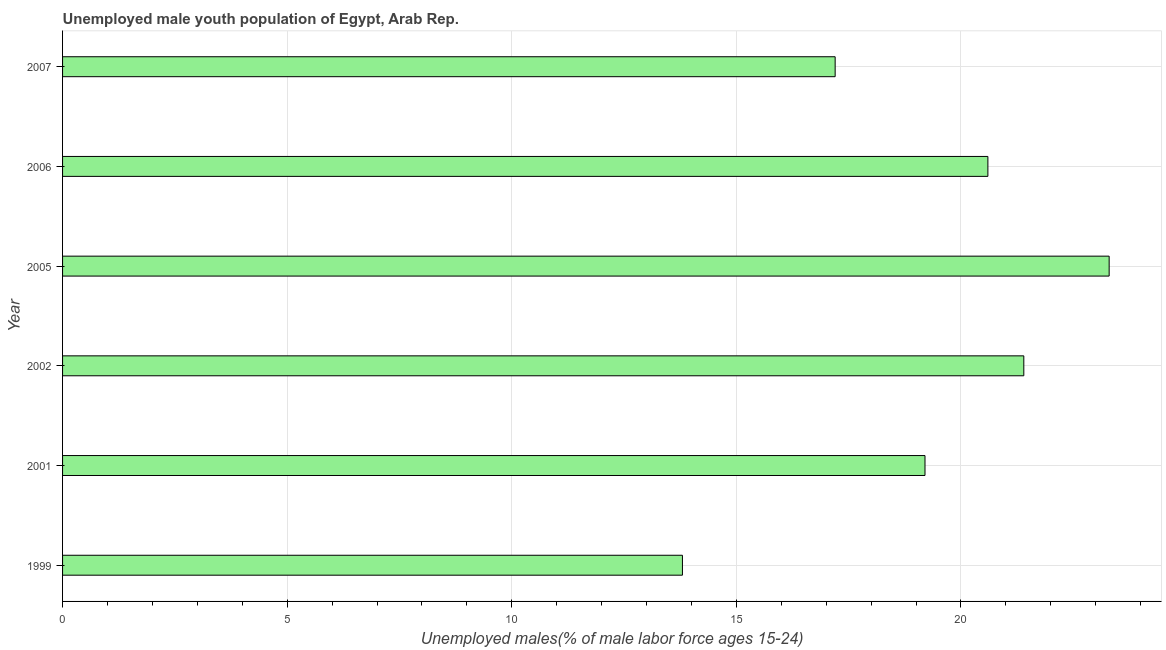What is the title of the graph?
Make the answer very short. Unemployed male youth population of Egypt, Arab Rep. What is the label or title of the X-axis?
Make the answer very short. Unemployed males(% of male labor force ages 15-24). What is the unemployed male youth in 2007?
Ensure brevity in your answer.  17.2. Across all years, what is the maximum unemployed male youth?
Ensure brevity in your answer.  23.3. Across all years, what is the minimum unemployed male youth?
Your answer should be very brief. 13.8. In which year was the unemployed male youth maximum?
Make the answer very short. 2005. What is the sum of the unemployed male youth?
Keep it short and to the point. 115.5. What is the average unemployed male youth per year?
Provide a short and direct response. 19.25. What is the median unemployed male youth?
Give a very brief answer. 19.9. In how many years, is the unemployed male youth greater than 6 %?
Provide a short and direct response. 6. Do a majority of the years between 1999 and 2006 (inclusive) have unemployed male youth greater than 17 %?
Ensure brevity in your answer.  Yes. What is the ratio of the unemployed male youth in 2006 to that in 2007?
Make the answer very short. 1.2. Is the sum of the unemployed male youth in 2002 and 2007 greater than the maximum unemployed male youth across all years?
Provide a succinct answer. Yes. What is the Unemployed males(% of male labor force ages 15-24) in 1999?
Provide a succinct answer. 13.8. What is the Unemployed males(% of male labor force ages 15-24) of 2001?
Ensure brevity in your answer.  19.2. What is the Unemployed males(% of male labor force ages 15-24) in 2002?
Your answer should be compact. 21.4. What is the Unemployed males(% of male labor force ages 15-24) in 2005?
Ensure brevity in your answer.  23.3. What is the Unemployed males(% of male labor force ages 15-24) of 2006?
Make the answer very short. 20.6. What is the Unemployed males(% of male labor force ages 15-24) in 2007?
Provide a succinct answer. 17.2. What is the difference between the Unemployed males(% of male labor force ages 15-24) in 1999 and 2001?
Ensure brevity in your answer.  -5.4. What is the difference between the Unemployed males(% of male labor force ages 15-24) in 1999 and 2002?
Offer a very short reply. -7.6. What is the difference between the Unemployed males(% of male labor force ages 15-24) in 2001 and 2002?
Keep it short and to the point. -2.2. What is the difference between the Unemployed males(% of male labor force ages 15-24) in 2001 and 2005?
Offer a terse response. -4.1. What is the difference between the Unemployed males(% of male labor force ages 15-24) in 2001 and 2006?
Keep it short and to the point. -1.4. What is the difference between the Unemployed males(% of male labor force ages 15-24) in 2001 and 2007?
Your response must be concise. 2. What is the difference between the Unemployed males(% of male labor force ages 15-24) in 2002 and 2006?
Make the answer very short. 0.8. What is the difference between the Unemployed males(% of male labor force ages 15-24) in 2002 and 2007?
Your answer should be very brief. 4.2. What is the difference between the Unemployed males(% of male labor force ages 15-24) in 2005 and 2007?
Ensure brevity in your answer.  6.1. What is the difference between the Unemployed males(% of male labor force ages 15-24) in 2006 and 2007?
Offer a terse response. 3.4. What is the ratio of the Unemployed males(% of male labor force ages 15-24) in 1999 to that in 2001?
Offer a terse response. 0.72. What is the ratio of the Unemployed males(% of male labor force ages 15-24) in 1999 to that in 2002?
Provide a short and direct response. 0.65. What is the ratio of the Unemployed males(% of male labor force ages 15-24) in 1999 to that in 2005?
Your answer should be very brief. 0.59. What is the ratio of the Unemployed males(% of male labor force ages 15-24) in 1999 to that in 2006?
Your answer should be very brief. 0.67. What is the ratio of the Unemployed males(% of male labor force ages 15-24) in 1999 to that in 2007?
Provide a succinct answer. 0.8. What is the ratio of the Unemployed males(% of male labor force ages 15-24) in 2001 to that in 2002?
Give a very brief answer. 0.9. What is the ratio of the Unemployed males(% of male labor force ages 15-24) in 2001 to that in 2005?
Offer a terse response. 0.82. What is the ratio of the Unemployed males(% of male labor force ages 15-24) in 2001 to that in 2006?
Make the answer very short. 0.93. What is the ratio of the Unemployed males(% of male labor force ages 15-24) in 2001 to that in 2007?
Offer a very short reply. 1.12. What is the ratio of the Unemployed males(% of male labor force ages 15-24) in 2002 to that in 2005?
Offer a terse response. 0.92. What is the ratio of the Unemployed males(% of male labor force ages 15-24) in 2002 to that in 2006?
Ensure brevity in your answer.  1.04. What is the ratio of the Unemployed males(% of male labor force ages 15-24) in 2002 to that in 2007?
Ensure brevity in your answer.  1.24. What is the ratio of the Unemployed males(% of male labor force ages 15-24) in 2005 to that in 2006?
Your answer should be very brief. 1.13. What is the ratio of the Unemployed males(% of male labor force ages 15-24) in 2005 to that in 2007?
Ensure brevity in your answer.  1.35. What is the ratio of the Unemployed males(% of male labor force ages 15-24) in 2006 to that in 2007?
Offer a terse response. 1.2. 